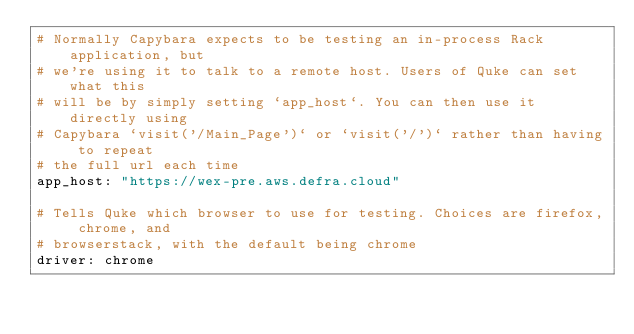Convert code to text. <code><loc_0><loc_0><loc_500><loc_500><_YAML_># Normally Capybara expects to be testing an in-process Rack application, but
# we're using it to talk to a remote host. Users of Quke can set what this
# will be by simply setting `app_host`. You can then use it directly using
# Capybara `visit('/Main_Page')` or `visit('/')` rather than having to repeat
# the full url each time
app_host: "https://wex-pre.aws.defra.cloud"

# Tells Quke which browser to use for testing. Choices are firefox, chrome, and
# browserstack, with the default being chrome
driver: chrome
</code> 